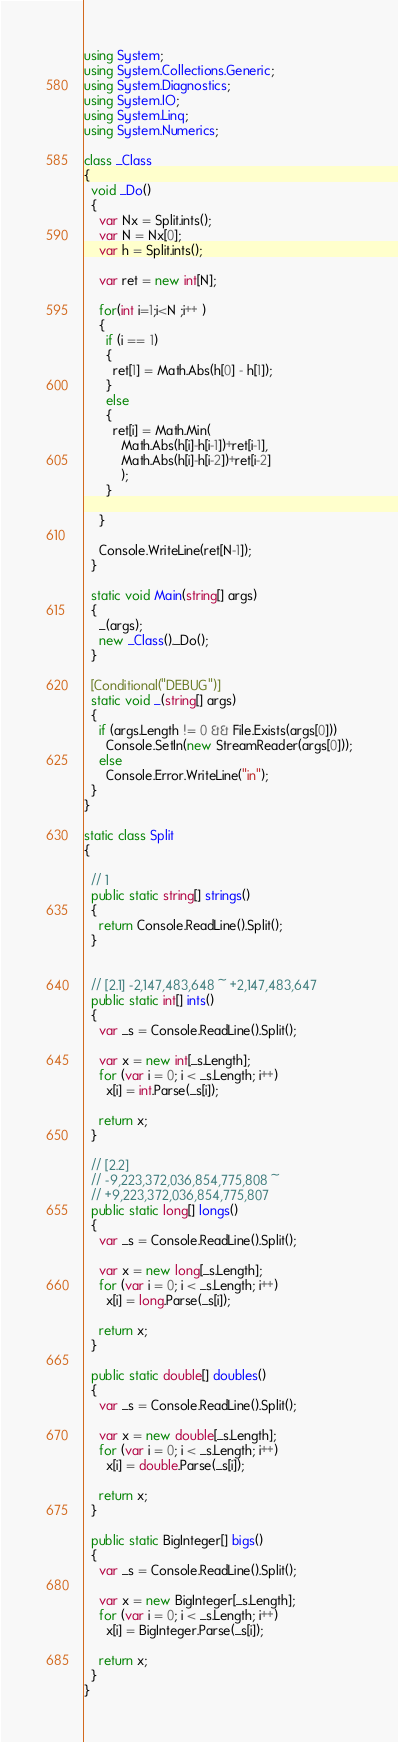Convert code to text. <code><loc_0><loc_0><loc_500><loc_500><_C#_>using System;
using System.Collections.Generic;
using System.Diagnostics;
using System.IO;
using System.Linq;
using System.Numerics;

class _Class
{
  void _Do()
  {
    var Nx = Split.ints();
    var N = Nx[0];
    var h = Split.ints();

    var ret = new int[N];

    for(int i=1;i<N ;i++ )
    {
      if (i == 1)
      {
        ret[1] = Math.Abs(h[0] - h[1]);
      }
      else
      {
        ret[i] = Math.Min(
          Math.Abs(h[i]-h[i-1])+ret[i-1],
          Math.Abs(h[i]-h[i-2])+ret[i-2]
          );
      }

    }

    Console.WriteLine(ret[N-1]);
  }

  static void Main(string[] args)
  {
    _(args);
    new _Class()._Do();
  }

  [Conditional("DEBUG")]
  static void _(string[] args)
  {
    if (args.Length != 0 && File.Exists(args[0]))
      Console.SetIn(new StreamReader(args[0]));
    else
      Console.Error.WriteLine("in");
  }
}

static class Split
{ 

  // 1
  public static string[] strings()
  {
    return Console.ReadLine().Split();
  }


  // [2.1] -2,147,483,648 ~ +2,147,483,647
  public static int[] ints()
  {
    var _s = Console.ReadLine().Split();

    var x = new int[_s.Length];
    for (var i = 0; i < _s.Length; i++)
      x[i] = int.Parse(_s[i]);

    return x;
  }

  // [2.2] 
  // -9,223,372,036,854,775,808 ~ 
  // +9,223,372,036,854,775,807
  public static long[] longs()
  {
    var _s = Console.ReadLine().Split();

    var x = new long[_s.Length];
    for (var i = 0; i < _s.Length; i++)
      x[i] = long.Parse(_s[i]);

    return x;
  }

  public static double[] doubles()
  {
    var _s = Console.ReadLine().Split();

    var x = new double[_s.Length];
    for (var i = 0; i < _s.Length; i++)
      x[i] = double.Parse(_s[i]);

    return x;
  }

  public static BigInteger[] bigs()
  {
    var _s = Console.ReadLine().Split();

    var x = new BigInteger[_s.Length];
    for (var i = 0; i < _s.Length; i++)
      x[i] = BigInteger.Parse(_s[i]);

    return x;
  }
}

</code> 